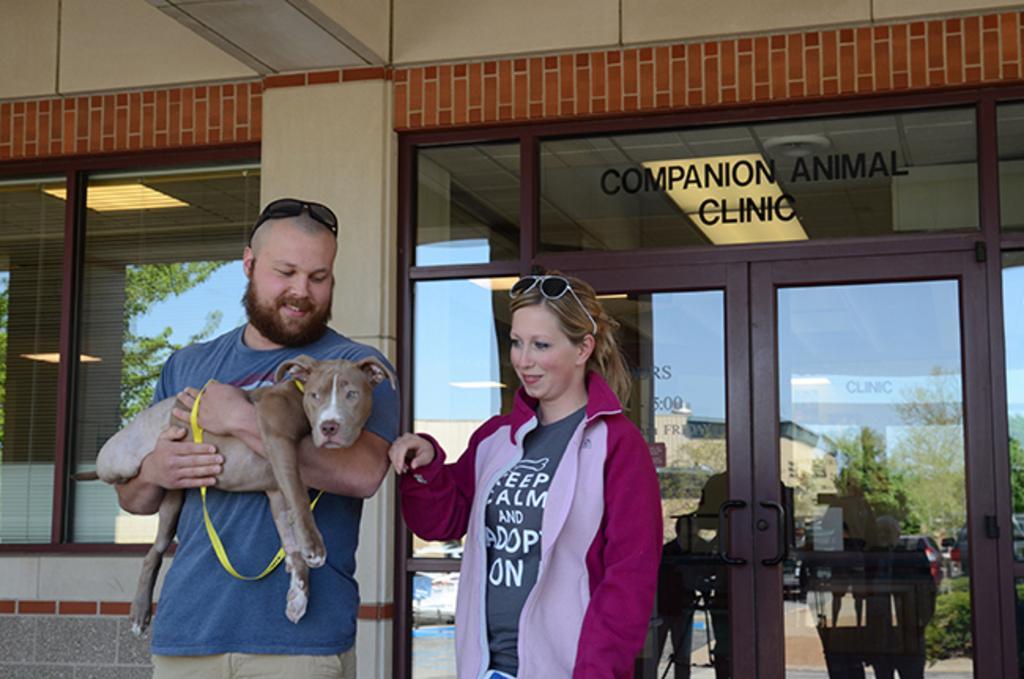Describe this image in one or two sentences. In this image In the middle there is a woman she wear t shirt and jacket she is smiling. On the left there is a man he wear blue t shirt and trouser he is holding a dog. In the background there is a door, window, text and glass. 